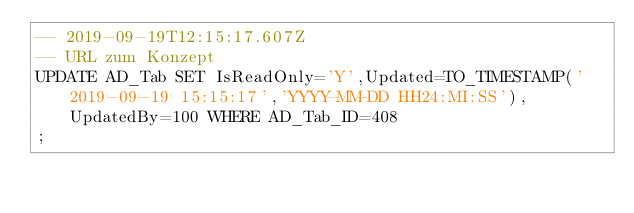Convert code to text. <code><loc_0><loc_0><loc_500><loc_500><_SQL_>-- 2019-09-19T12:15:17.607Z
-- URL zum Konzept
UPDATE AD_Tab SET IsReadOnly='Y',Updated=TO_TIMESTAMP('2019-09-19 15:15:17','YYYY-MM-DD HH24:MI:SS'),UpdatedBy=100 WHERE AD_Tab_ID=408
;

</code> 